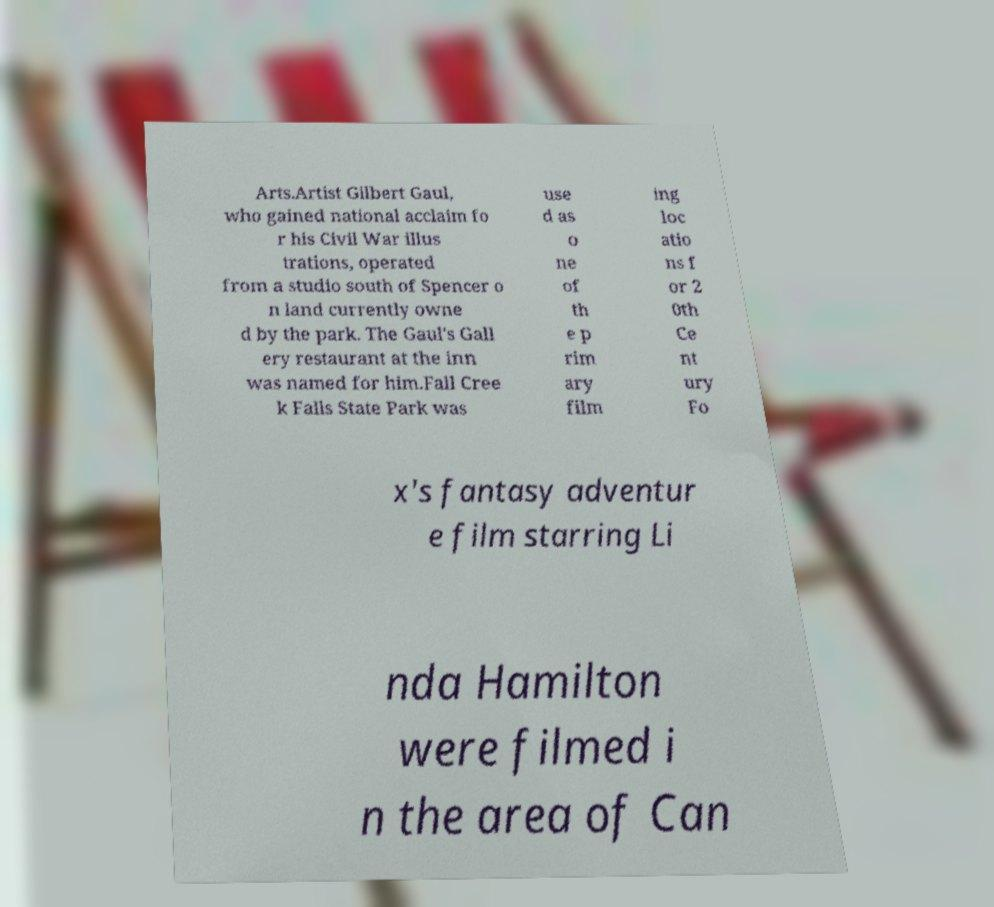Please identify and transcribe the text found in this image. Arts.Artist Gilbert Gaul, who gained national acclaim fo r his Civil War illus trations, operated from a studio south of Spencer o n land currently owne d by the park. The Gaul's Gall ery restaurant at the inn was named for him.Fall Cree k Falls State Park was use d as o ne of th e p rim ary film ing loc atio ns f or 2 0th Ce nt ury Fo x's fantasy adventur e film starring Li nda Hamilton were filmed i n the area of Can 